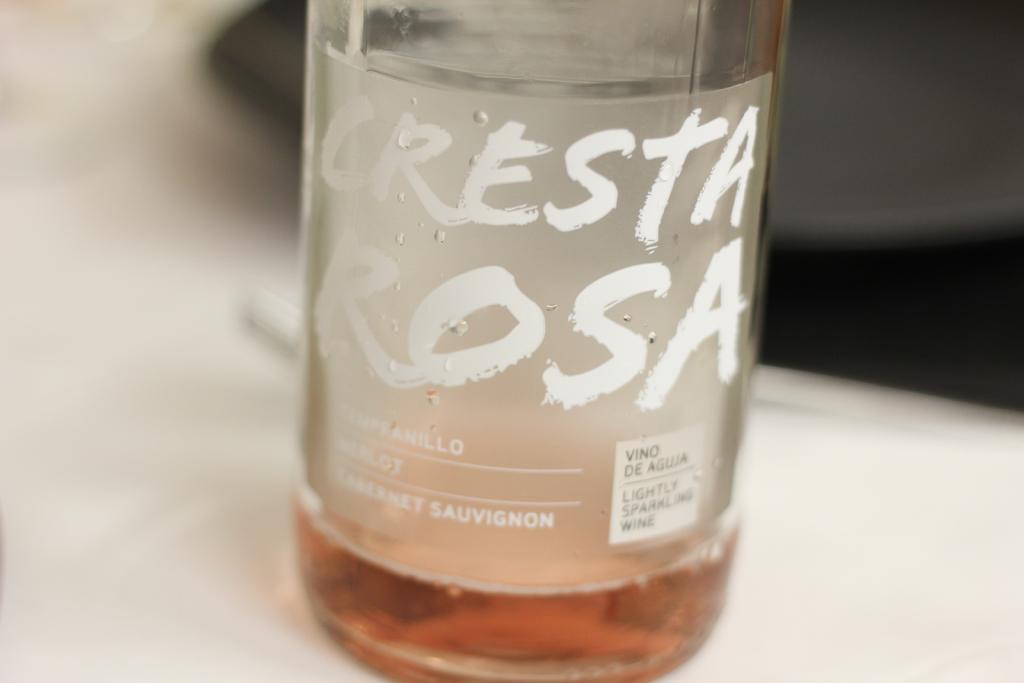What kind of drink is this?
Offer a very short reply. Cresta rosa. Who made this beverage?
Provide a short and direct response. Cresta rosa. 